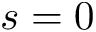Convert formula to latex. <formula><loc_0><loc_0><loc_500><loc_500>s = 0</formula> 